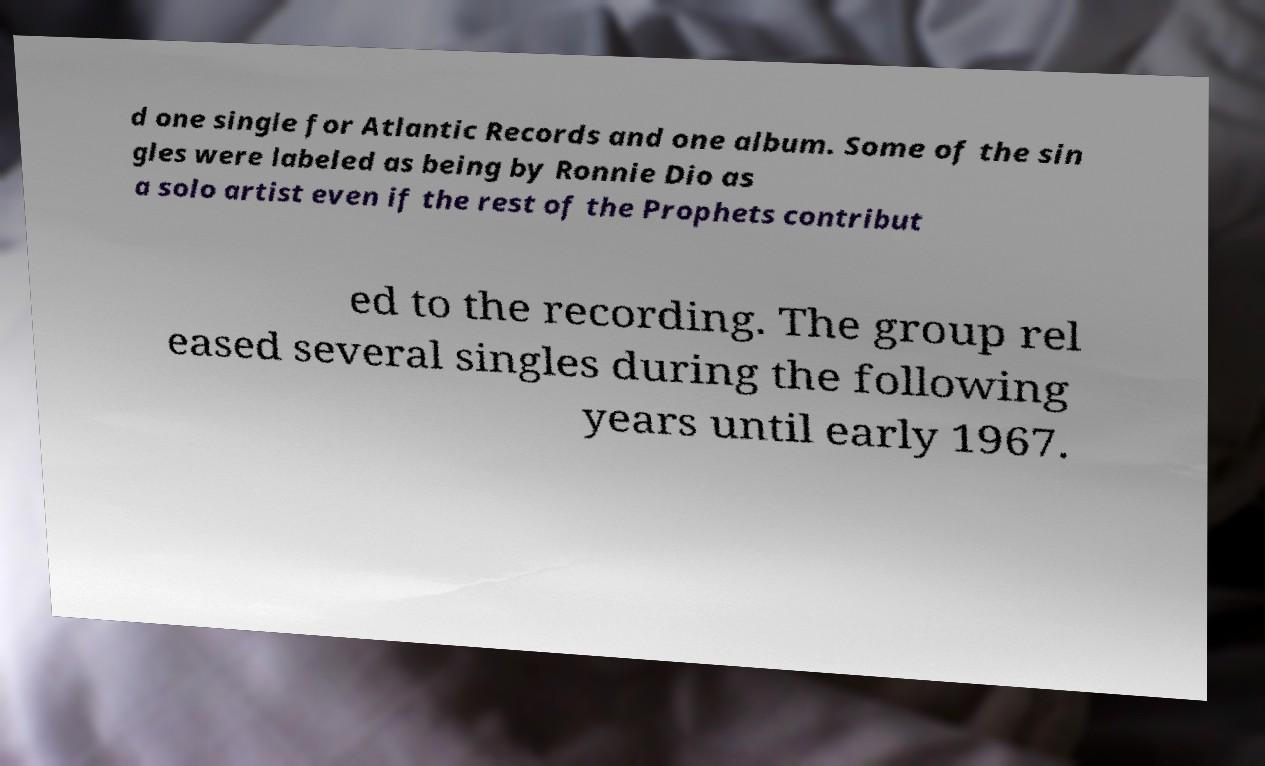Could you extract and type out the text from this image? d one single for Atlantic Records and one album. Some of the sin gles were labeled as being by Ronnie Dio as a solo artist even if the rest of the Prophets contribut ed to the recording. The group rel eased several singles during the following years until early 1967. 